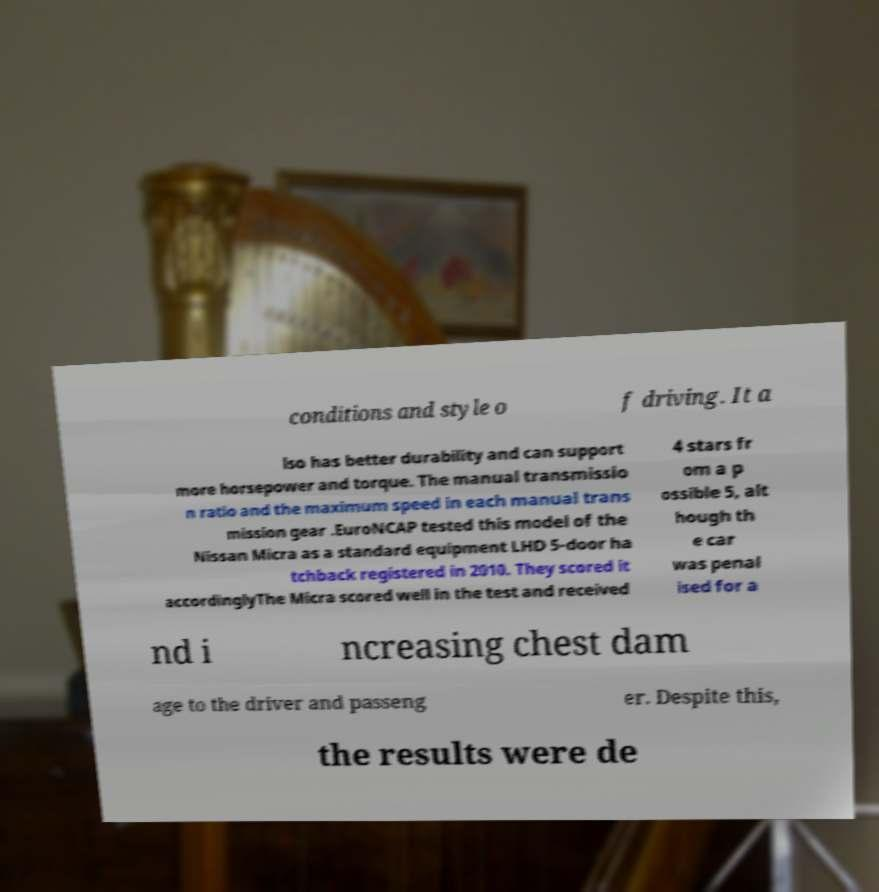For documentation purposes, I need the text within this image transcribed. Could you provide that? conditions and style o f driving. It a lso has better durability and can support more horsepower and torque. The manual transmissio n ratio and the maximum speed in each manual trans mission gear .EuroNCAP tested this model of the Nissan Micra as a standard equipment LHD 5-door ha tchback registered in 2010. They scored it accordinglyThe Micra scored well in the test and received 4 stars fr om a p ossible 5, alt hough th e car was penal ised for a nd i ncreasing chest dam age to the driver and passeng er. Despite this, the results were de 